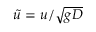<formula> <loc_0><loc_0><loc_500><loc_500>\tilde { u } = u / \sqrt { g D }</formula> 